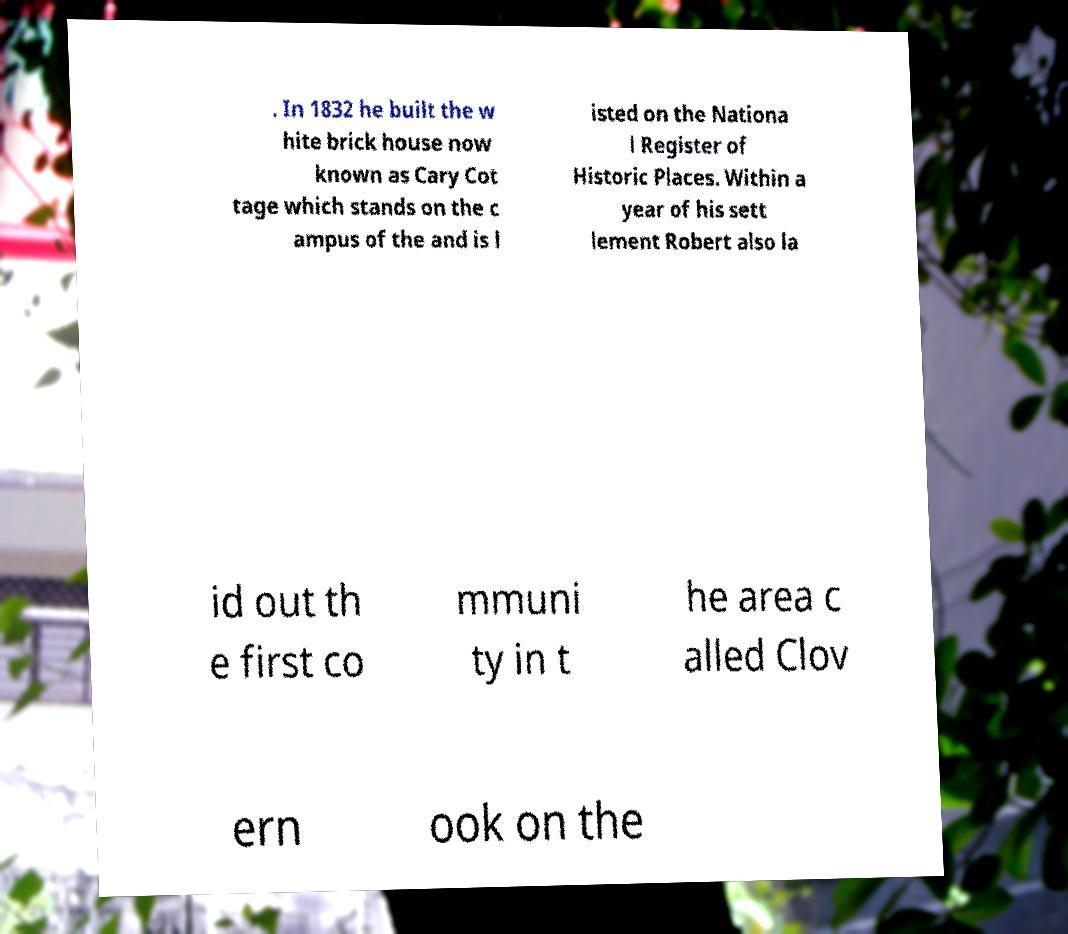Could you extract and type out the text from this image? . In 1832 he built the w hite brick house now known as Cary Cot tage which stands on the c ampus of the and is l isted on the Nationa l Register of Historic Places. Within a year of his sett lement Robert also la id out th e first co mmuni ty in t he area c alled Clov ern ook on the 